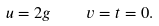Convert formula to latex. <formula><loc_0><loc_0><loc_500><loc_500>u = 2 g \quad v = t = 0 .</formula> 